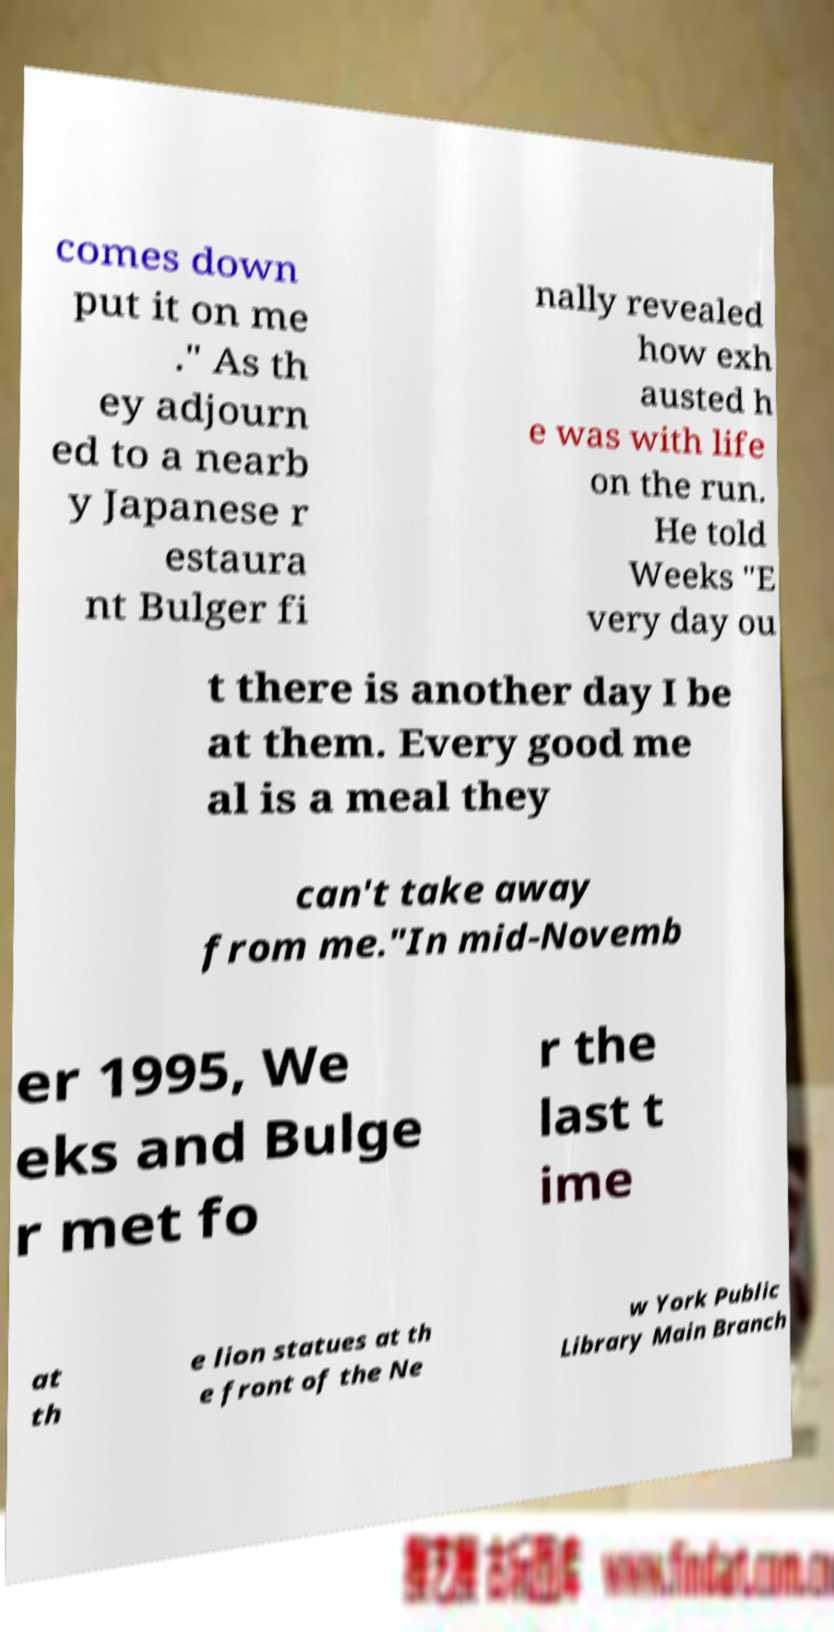For documentation purposes, I need the text within this image transcribed. Could you provide that? comes down put it on me ." As th ey adjourn ed to a nearb y Japanese r estaura nt Bulger fi nally revealed how exh austed h e was with life on the run. He told Weeks "E very day ou t there is another day I be at them. Every good me al is a meal they can't take away from me."In mid-Novemb er 1995, We eks and Bulge r met fo r the last t ime at th e lion statues at th e front of the Ne w York Public Library Main Branch 